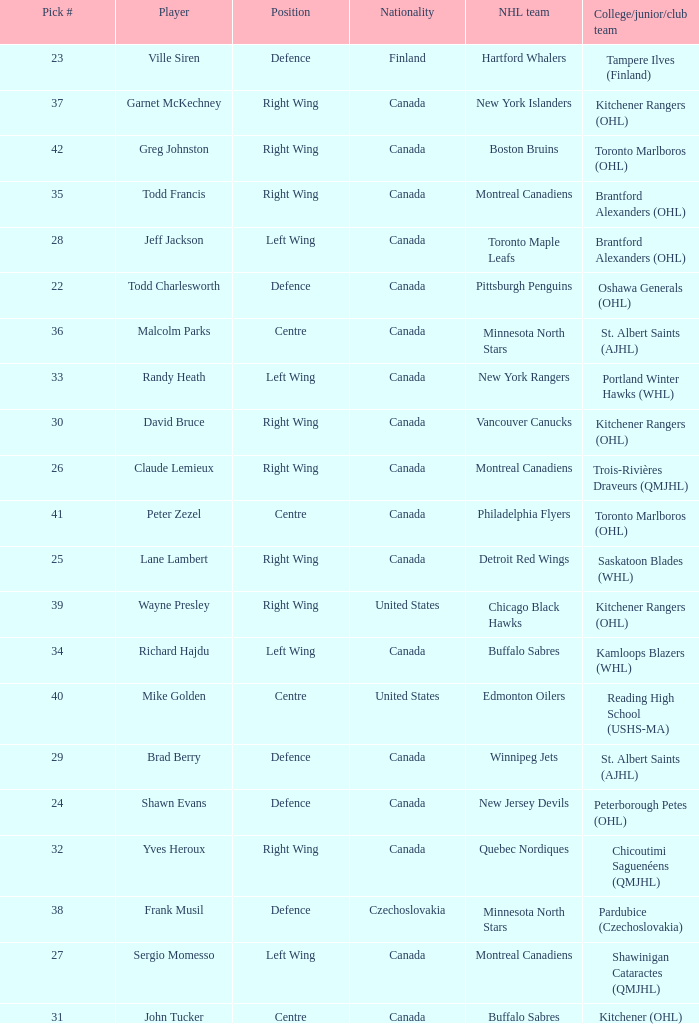Could you parse the entire table as a dict? {'header': ['Pick #', 'Player', 'Position', 'Nationality', 'NHL team', 'College/junior/club team'], 'rows': [['23', 'Ville Siren', 'Defence', 'Finland', 'Hartford Whalers', 'Tampere Ilves (Finland)'], ['37', 'Garnet McKechney', 'Right Wing', 'Canada', 'New York Islanders', 'Kitchener Rangers (OHL)'], ['42', 'Greg Johnston', 'Right Wing', 'Canada', 'Boston Bruins', 'Toronto Marlboros (OHL)'], ['35', 'Todd Francis', 'Right Wing', 'Canada', 'Montreal Canadiens', 'Brantford Alexanders (OHL)'], ['28', 'Jeff Jackson', 'Left Wing', 'Canada', 'Toronto Maple Leafs', 'Brantford Alexanders (OHL)'], ['22', 'Todd Charlesworth', 'Defence', 'Canada', 'Pittsburgh Penguins', 'Oshawa Generals (OHL)'], ['36', 'Malcolm Parks', 'Centre', 'Canada', 'Minnesota North Stars', 'St. Albert Saints (AJHL)'], ['33', 'Randy Heath', 'Left Wing', 'Canada', 'New York Rangers', 'Portland Winter Hawks (WHL)'], ['30', 'David Bruce', 'Right Wing', 'Canada', 'Vancouver Canucks', 'Kitchener Rangers (OHL)'], ['26', 'Claude Lemieux', 'Right Wing', 'Canada', 'Montreal Canadiens', 'Trois-Rivières Draveurs (QMJHL)'], ['41', 'Peter Zezel', 'Centre', 'Canada', 'Philadelphia Flyers', 'Toronto Marlboros (OHL)'], ['25', 'Lane Lambert', 'Right Wing', 'Canada', 'Detroit Red Wings', 'Saskatoon Blades (WHL)'], ['39', 'Wayne Presley', 'Right Wing', 'United States', 'Chicago Black Hawks', 'Kitchener Rangers (OHL)'], ['34', 'Richard Hajdu', 'Left Wing', 'Canada', 'Buffalo Sabres', 'Kamloops Blazers (WHL)'], ['40', 'Mike Golden', 'Centre', 'United States', 'Edmonton Oilers', 'Reading High School (USHS-MA)'], ['29', 'Brad Berry', 'Defence', 'Canada', 'Winnipeg Jets', 'St. Albert Saints (AJHL)'], ['24', 'Shawn Evans', 'Defence', 'Canada', 'New Jersey Devils', 'Peterborough Petes (OHL)'], ['32', 'Yves Heroux', 'Right Wing', 'Canada', 'Quebec Nordiques', 'Chicoutimi Saguenéens (QMJHL)'], ['38', 'Frank Musil', 'Defence', 'Czechoslovakia', 'Minnesota North Stars', 'Pardubice (Czechoslovakia)'], ['27', 'Sergio Momesso', 'Left Wing', 'Canada', 'Montreal Canadiens', 'Shawinigan Cataractes (QMJHL)'], ['31', 'John Tucker', 'Centre', 'Canada', 'Buffalo Sabres', 'Kitchener (OHL)']]} What is the nhl team when the college, junior, club team is toronto marlboros (ohl) and the position is centre? Philadelphia Flyers. 